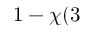Convert formula to latex. <formula><loc_0><loc_0><loc_500><loc_500>1 - \chi ( 3</formula> 